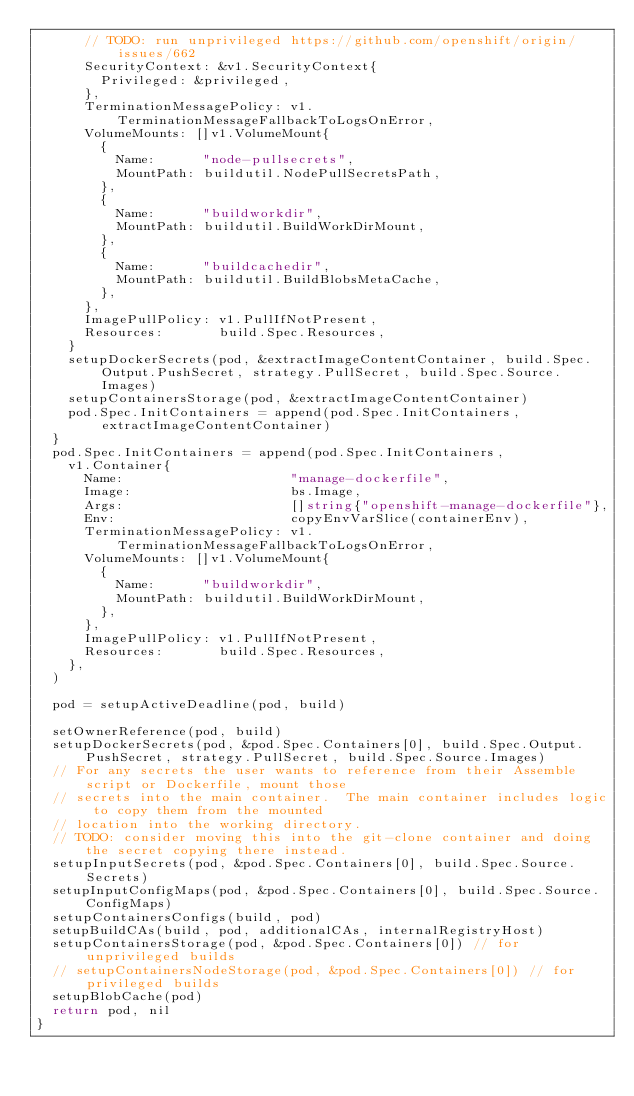<code> <loc_0><loc_0><loc_500><loc_500><_Go_>			// TODO: run unprivileged https://github.com/openshift/origin/issues/662
			SecurityContext: &v1.SecurityContext{
				Privileged: &privileged,
			},
			TerminationMessagePolicy: v1.TerminationMessageFallbackToLogsOnError,
			VolumeMounts: []v1.VolumeMount{
				{
					Name:      "node-pullsecrets",
					MountPath: buildutil.NodePullSecretsPath,
				},
				{
					Name:      "buildworkdir",
					MountPath: buildutil.BuildWorkDirMount,
				},
				{
					Name:      "buildcachedir",
					MountPath: buildutil.BuildBlobsMetaCache,
				},
			},
			ImagePullPolicy: v1.PullIfNotPresent,
			Resources:       build.Spec.Resources,
		}
		setupDockerSecrets(pod, &extractImageContentContainer, build.Spec.Output.PushSecret, strategy.PullSecret, build.Spec.Source.Images)
		setupContainersStorage(pod, &extractImageContentContainer)
		pod.Spec.InitContainers = append(pod.Spec.InitContainers, extractImageContentContainer)
	}
	pod.Spec.InitContainers = append(pod.Spec.InitContainers,
		v1.Container{
			Name:                     "manage-dockerfile",
			Image:                    bs.Image,
			Args:                     []string{"openshift-manage-dockerfile"},
			Env:                      copyEnvVarSlice(containerEnv),
			TerminationMessagePolicy: v1.TerminationMessageFallbackToLogsOnError,
			VolumeMounts: []v1.VolumeMount{
				{
					Name:      "buildworkdir",
					MountPath: buildutil.BuildWorkDirMount,
				},
			},
			ImagePullPolicy: v1.PullIfNotPresent,
			Resources:       build.Spec.Resources,
		},
	)

	pod = setupActiveDeadline(pod, build)

	setOwnerReference(pod, build)
	setupDockerSecrets(pod, &pod.Spec.Containers[0], build.Spec.Output.PushSecret, strategy.PullSecret, build.Spec.Source.Images)
	// For any secrets the user wants to reference from their Assemble script or Dockerfile, mount those
	// secrets into the main container.  The main container includes logic to copy them from the mounted
	// location into the working directory.
	// TODO: consider moving this into the git-clone container and doing the secret copying there instead.
	setupInputSecrets(pod, &pod.Spec.Containers[0], build.Spec.Source.Secrets)
	setupInputConfigMaps(pod, &pod.Spec.Containers[0], build.Spec.Source.ConfigMaps)
	setupContainersConfigs(build, pod)
	setupBuildCAs(build, pod, additionalCAs, internalRegistryHost)
	setupContainersStorage(pod, &pod.Spec.Containers[0]) // for unprivileged builds
	// setupContainersNodeStorage(pod, &pod.Spec.Containers[0]) // for privileged builds
	setupBlobCache(pod)
	return pod, nil
}
</code> 